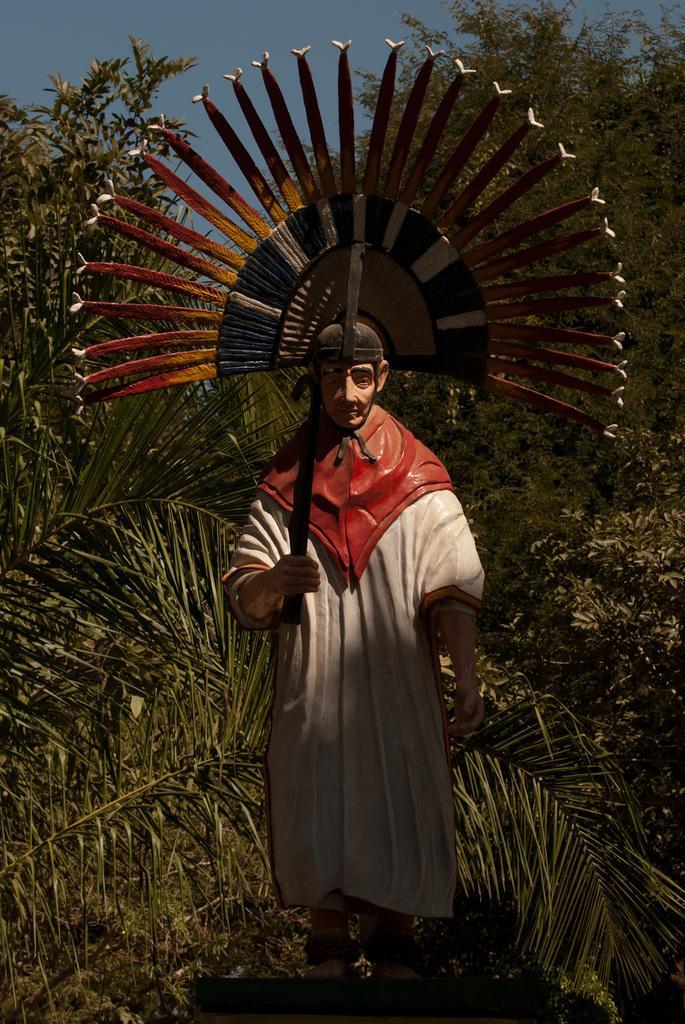In one or two sentences, can you explain what this image depicts? In this picture there is a statue of a person standing. At the back there are trees. At the top there is sky. 